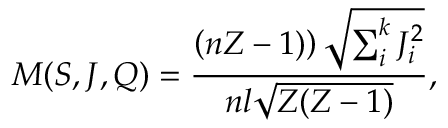<formula> <loc_0><loc_0><loc_500><loc_500>M ( S , J , Q ) = \frac { \left ( n Z - 1 ) \right ) \sqrt { \sum _ { i } ^ { k } J _ { i } ^ { 2 } } } { n l \sqrt { Z ( Z - 1 ) } } ,</formula> 